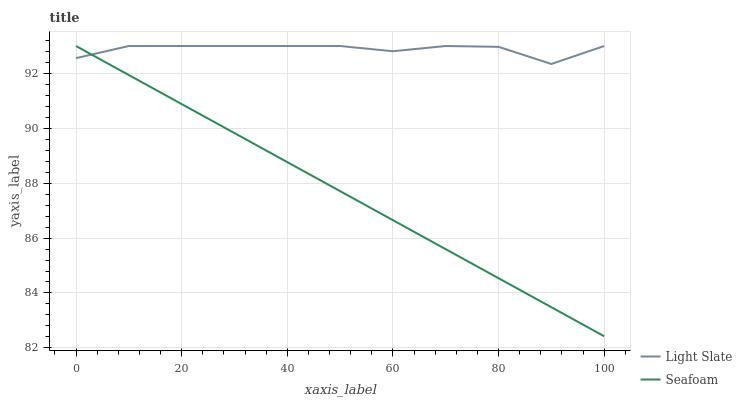Does Seafoam have the minimum area under the curve?
Answer yes or no. Yes. Does Light Slate have the maximum area under the curve?
Answer yes or no. Yes. Does Seafoam have the maximum area under the curve?
Answer yes or no. No. Is Seafoam the smoothest?
Answer yes or no. Yes. Is Light Slate the roughest?
Answer yes or no. Yes. Is Seafoam the roughest?
Answer yes or no. No. Does Seafoam have the lowest value?
Answer yes or no. Yes. Does Seafoam have the highest value?
Answer yes or no. Yes. Does Seafoam intersect Light Slate?
Answer yes or no. Yes. Is Seafoam less than Light Slate?
Answer yes or no. No. Is Seafoam greater than Light Slate?
Answer yes or no. No. 